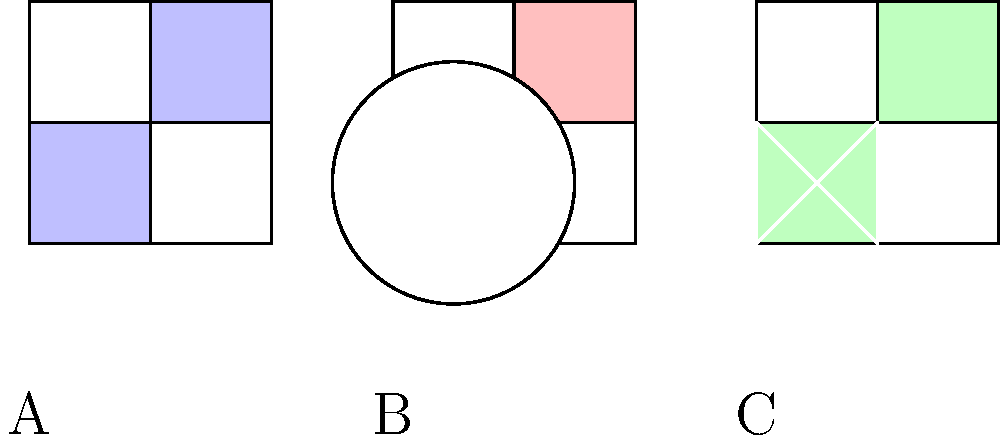Based on the visual comparison of antique quilting patterns shown above, which pattern is most likely associated with the Amish quilting tradition from Pennsylvania? To answer this question, let's analyze each quilting pattern:

1. Pattern A: This pattern shows a simple four-square design with alternating colors. While it's a common quilt pattern, it's not specifically associated with Amish quilting.

2. Pattern B: This pattern features a circular design within a square. Circular patterns are less common in traditional Amish quilting, as they often prefer geometric shapes with straight lines.

3. Pattern C: This pattern displays a diamond shape within a square, creating a "diamond in a square" or "square in a square" effect. This is a characteristic feature of Amish quilting from Pennsylvania.

Key points about Amish quilting from Pennsylvania:
- Amish quilts are known for their simplicity and bold geometric designs.
- They often feature large, solid-colored areas with contrasting colors.
- Common patterns include diamonds, squares, and triangles.
- Circular patterns are less common in traditional Amish quilts.

Pattern C best exemplifies these characteristics with its diamond shape and simple geometric design, making it the most likely to be associated with the Amish quilting tradition from Pennsylvania.
Answer: Pattern C 